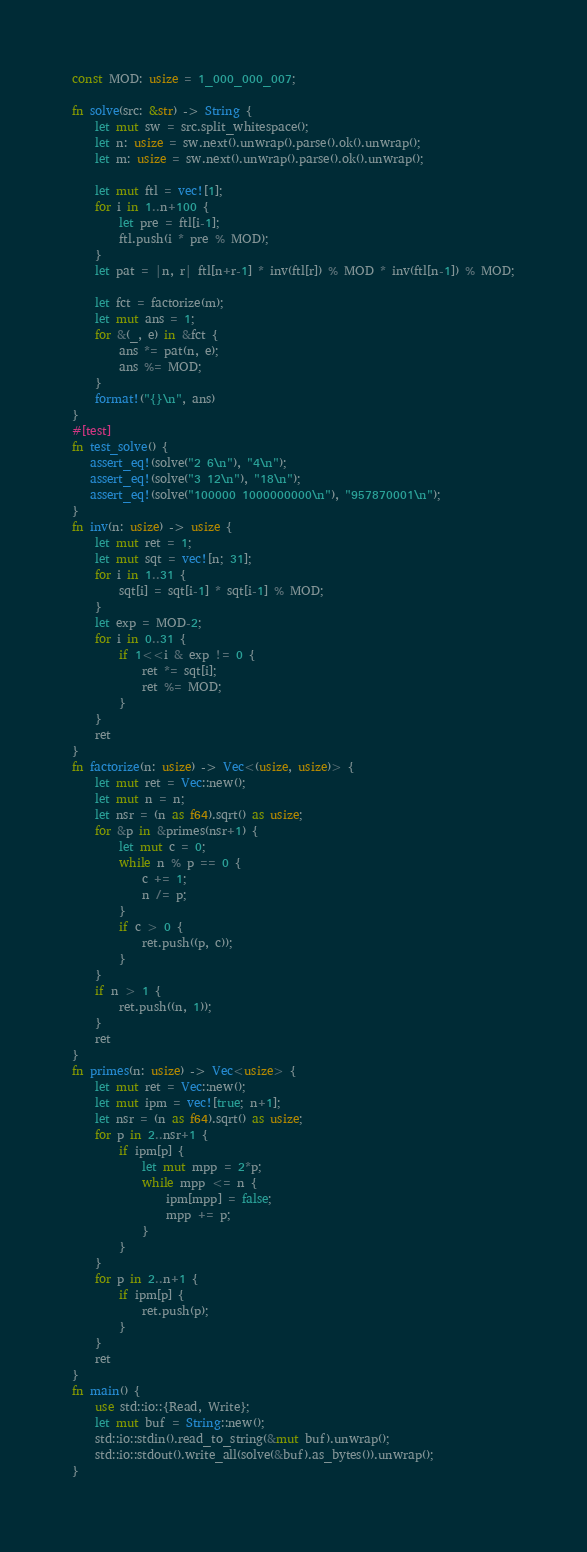<code> <loc_0><loc_0><loc_500><loc_500><_Rust_>const MOD: usize = 1_000_000_007;

fn solve(src: &str) -> String {
    let mut sw = src.split_whitespace();
    let n: usize = sw.next().unwrap().parse().ok().unwrap();
    let m: usize = sw.next().unwrap().parse().ok().unwrap();

    let mut ftl = vec![1];
    for i in 1..n+100 {
        let pre = ftl[i-1];
        ftl.push(i * pre % MOD);
    }
    let pat = |n, r| ftl[n+r-1] * inv(ftl[r]) % MOD * inv(ftl[n-1]) % MOD;
    
    let fct = factorize(m);
    let mut ans = 1;
    for &(_, e) in &fct {
        ans *= pat(n, e);
        ans %= MOD;
    }
    format!("{}\n", ans)
}
#[test]
fn test_solve() {
   assert_eq!(solve("2 6\n"), "4\n");
   assert_eq!(solve("3 12\n"), "18\n");
   assert_eq!(solve("100000 1000000000\n"), "957870001\n");
}
fn inv(n: usize) -> usize {
    let mut ret = 1;
    let mut sqt = vec![n; 31];
    for i in 1..31 {
        sqt[i] = sqt[i-1] * sqt[i-1] % MOD;
    }
    let exp = MOD-2;
    for i in 0..31 {
        if 1<<i & exp != 0 {
            ret *= sqt[i];
            ret %= MOD;
        }
    }
    ret
}
fn factorize(n: usize) -> Vec<(usize, usize)> {
    let mut ret = Vec::new();
    let mut n = n;
    let nsr = (n as f64).sqrt() as usize;
    for &p in &primes(nsr+1) {
        let mut c = 0;
        while n % p == 0 {
            c += 1;
            n /= p;
        }
        if c > 0 {
            ret.push((p, c));
        }
    }
    if n > 1 {
        ret.push((n, 1));
    }
    ret
}
fn primes(n: usize) -> Vec<usize> {
    let mut ret = Vec::new();
    let mut ipm = vec![true; n+1];
    let nsr = (n as f64).sqrt() as usize;
    for p in 2..nsr+1 {
        if ipm[p] {
            let mut mpp = 2*p;
            while mpp <= n {
                ipm[mpp] = false;
                mpp += p;
            }
        }
    }
    for p in 2..n+1 {
        if ipm[p] {
            ret.push(p);
        }
    }
    ret
}
fn main() {
    use std::io::{Read, Write};
    let mut buf = String::new();
    std::io::stdin().read_to_string(&mut buf).unwrap();
    std::io::stdout().write_all(solve(&buf).as_bytes()).unwrap();
}</code> 